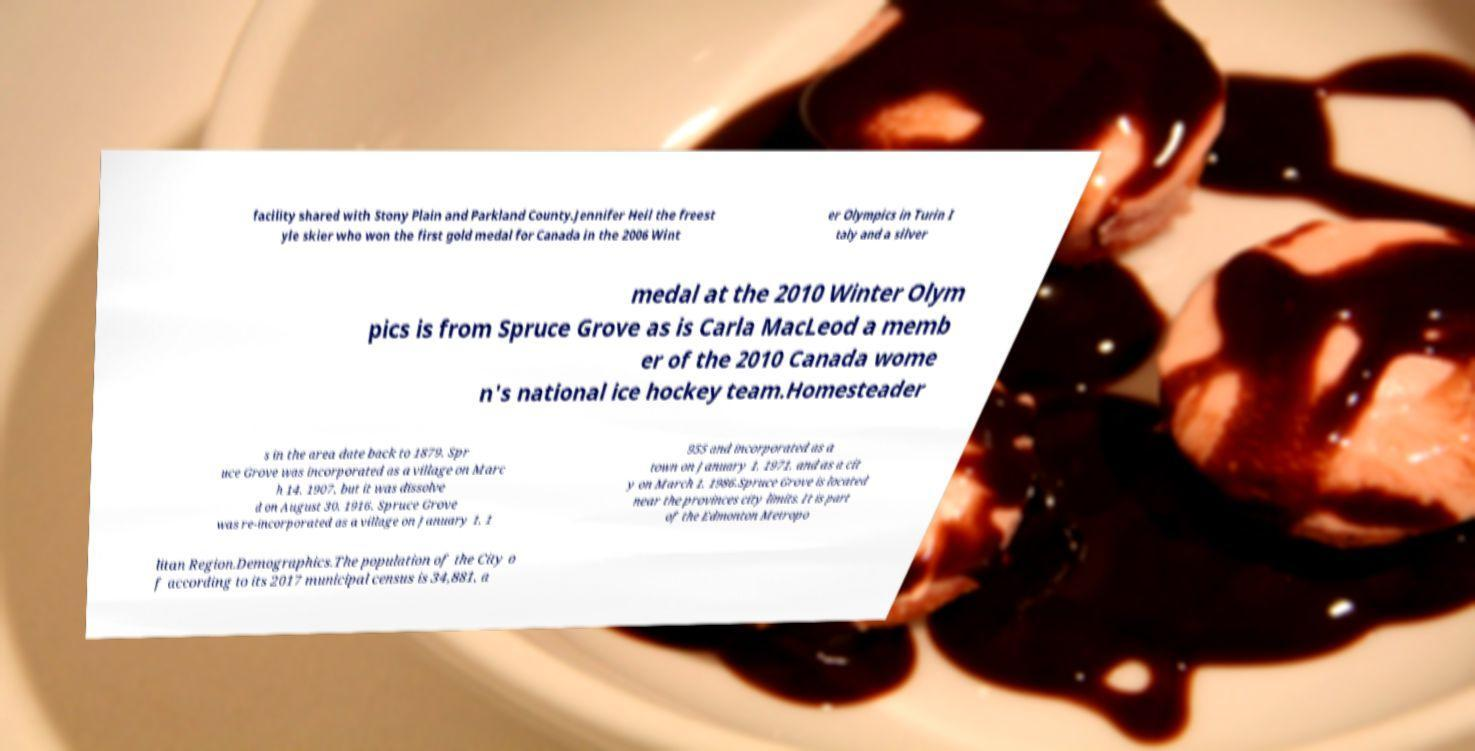For documentation purposes, I need the text within this image transcribed. Could you provide that? facility shared with Stony Plain and Parkland County.Jennifer Heil the freest yle skier who won the first gold medal for Canada in the 2006 Wint er Olympics in Turin I taly and a silver medal at the 2010 Winter Olym pics is from Spruce Grove as is Carla MacLeod a memb er of the 2010 Canada wome n's national ice hockey team.Homesteader s in the area date back to 1879. Spr uce Grove was incorporated as a village on Marc h 14, 1907, but it was dissolve d on August 30, 1916. Spruce Grove was re-incorporated as a village on January 1, 1 955 and incorporated as a town on January 1, 1971, and as a cit y on March 1, 1986.Spruce Grove is located near the provinces city limits. It is part of the Edmonton Metropo litan Region.Demographics.The population of the City o f according to its 2017 municipal census is 34,881, a 